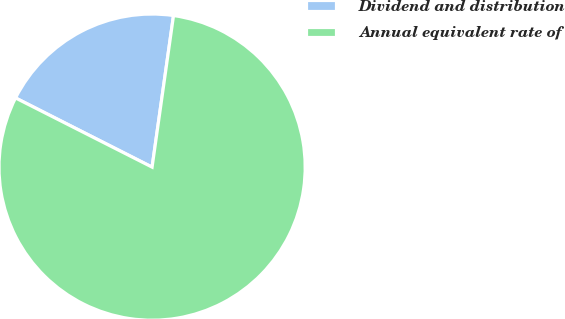Convert chart. <chart><loc_0><loc_0><loc_500><loc_500><pie_chart><fcel>Dividend and distribution<fcel>Annual equivalent rate of<nl><fcel>19.77%<fcel>80.23%<nl></chart> 